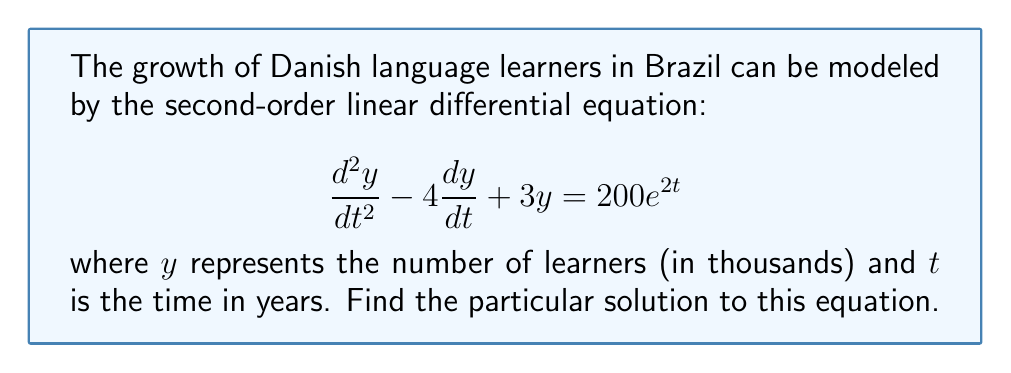Help me with this question. To find the particular solution, we'll use the method of undetermined coefficients:

1) The right-hand side of the equation is $200e^{2t}$, so we assume a particular solution of the form:

   $y_p = Ae^{2t}$

2) Substitute this into the original equation:

   $$(4A)e^{2t} - (8A)e^{2t} + 3Ae^{2t} = 200e^{2t}$$

3) Simplify:

   $$-Ae^{2t} = 200e^{2t}$$

4) Equate coefficients:

   $$-A = 200$$

5) Solve for A:

   $$A = -200$$

Therefore, the particular solution is:

$$y_p = -200e^{2t}$$
Answer: $y_p = -200e^{2t}$ 